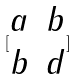Convert formula to latex. <formula><loc_0><loc_0><loc_500><loc_500>[ \begin{matrix} a & b \\ b & d \end{matrix} ]</formula> 